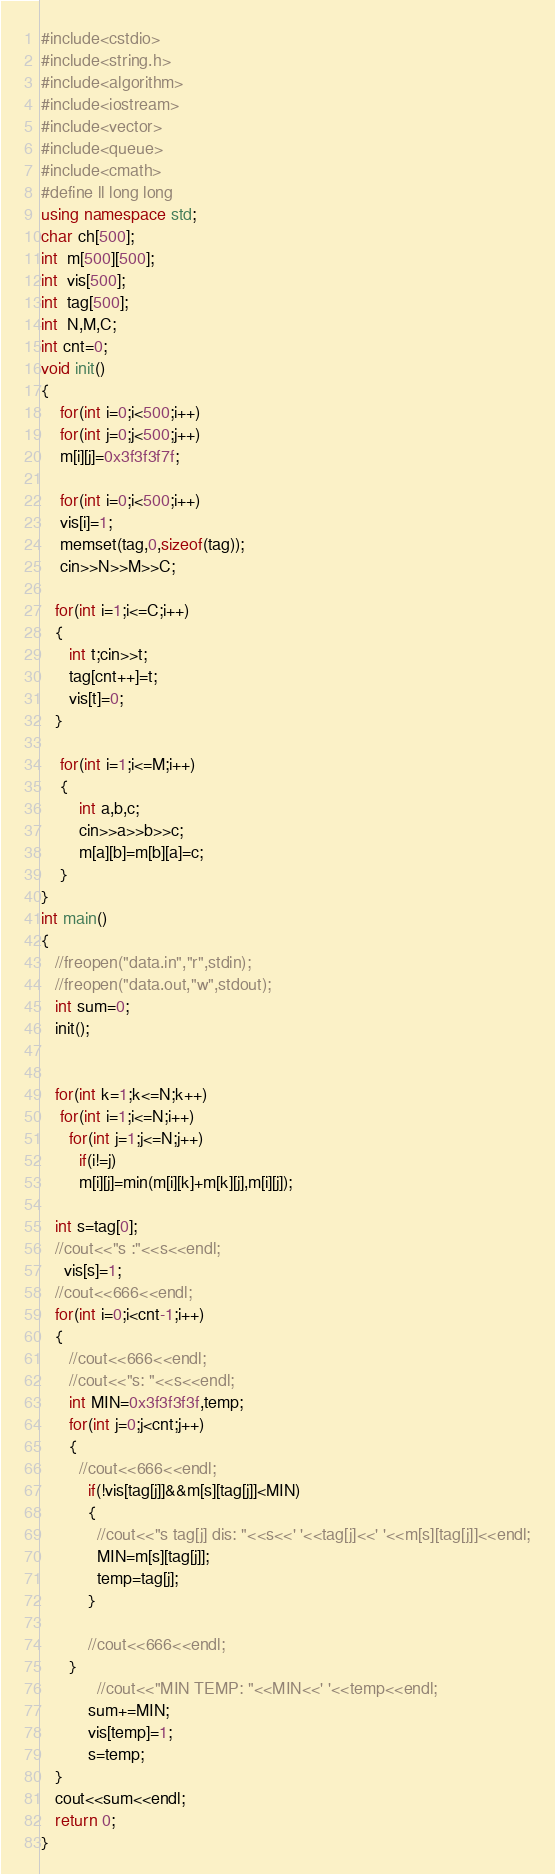Convert code to text. <code><loc_0><loc_0><loc_500><loc_500><_C++_>#include<cstdio>
#include<string.h>
#include<algorithm>
#include<iostream>
#include<vector>
#include<queue>
#include<cmath>
#define ll long long
using namespace std;
char ch[500];
int  m[500][500];
int  vis[500];
int  tag[500];
int  N,M,C;
int cnt=0;
void init()
{
	for(int i=0;i<500;i++)
	for(int j=0;j<500;j++)
	m[i][j]=0x3f3f3f7f;
	
	for(int i=0;i<500;i++)
	vis[i]=1;
	memset(tag,0,sizeof(tag));
	cin>>N>>M>>C;

   for(int i=1;i<=C;i++)
   {
   	  int t;cin>>t;
   	  tag[cnt++]=t;
   	  vis[t]=0;
   }

	for(int i=1;i<=M;i++)
	{
	   	int a,b,c;
	   	cin>>a>>b>>c;
	   	m[a][b]=m[b][a]=c;
	}
}
int main()
{
   //freopen("data.in","r",stdin);
   //freopen("data.out,"w",stdout);
   int sum=0;
   init();


   for(int k=1;k<=N;k++)
	for(int i=1;i<=N;i++)
	  for(int j=1;j<=N;j++)
	    if(i!=j)
		m[i][j]=min(m[i][k]+m[k][j],m[i][j]);

   int s=tag[0];
   //cout<<"s :"<<s<<endl;
     vis[s]=1;
   //cout<<666<<endl;
   for(int i=0;i<cnt-1;i++)
   {
   	  //cout<<666<<endl;
   	  //cout<<"s: "<<s<<endl;
   	  int MIN=0x3f3f3f3f,temp;
   	  for(int j=0;j<cnt;j++)
   	  {
   	  	//cout<<666<<endl;
   	      if(!vis[tag[j]]&&m[s][tag[j]]<MIN)
   	      {
   	      	//cout<<"s tag[j] dis: "<<s<<' '<<tag[j]<<' '<<m[s][tag[j]]<<endl;
   	        MIN=m[s][tag[j]];
			temp=tag[j];	
		  }

		  //cout<<666<<endl;
	  }
	  		//cout<<"MIN TEMP: "<<MIN<<' '<<temp<<endl;
		  sum+=MIN;
		  vis[temp]=1;
		  s=temp;
   }
   cout<<sum<<endl;
   return 0;
}
</code> 